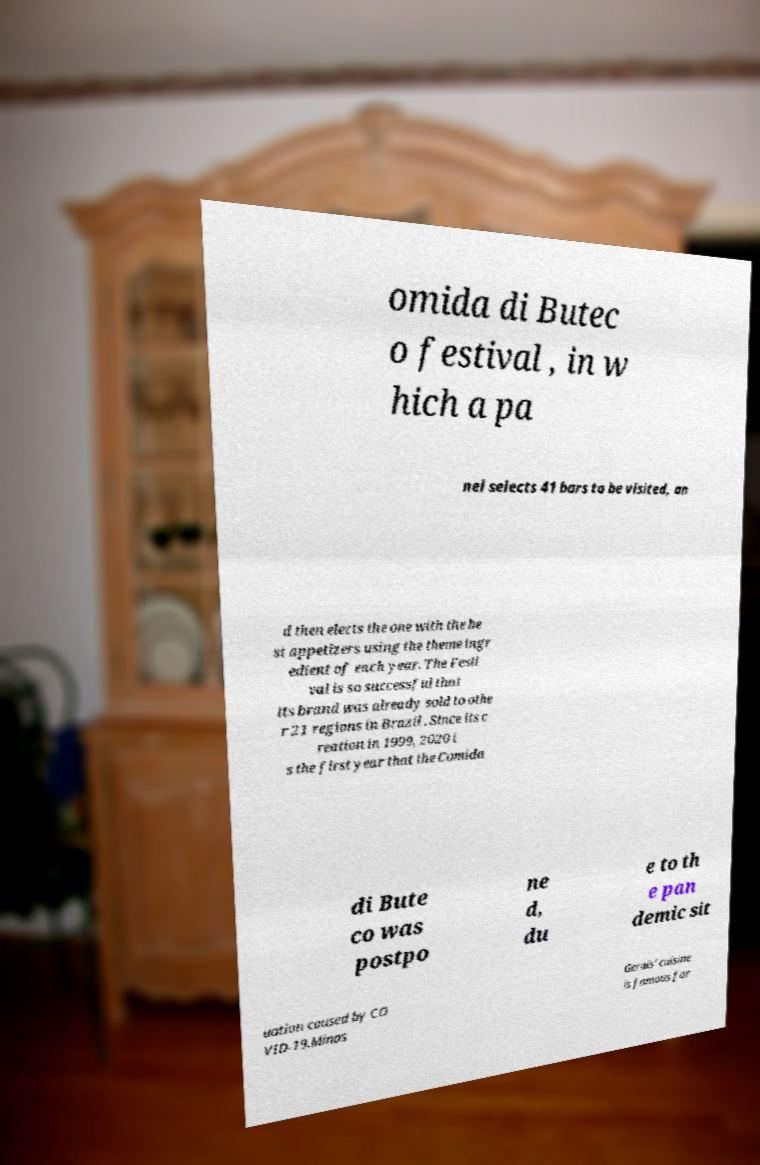Could you assist in decoding the text presented in this image and type it out clearly? omida di Butec o festival , in w hich a pa nel selects 41 bars to be visited, an d then elects the one with the be st appetizers using the theme ingr edient of each year. The Festi val is so successful that its brand was already sold to othe r 21 regions in Brazil . Since its c reation in 1999, 2020 i s the first year that the Comida di Bute co was postpo ne d, du e to th e pan demic sit uation caused by CO VID-19.Minas Gerais' cuisine is famous for 